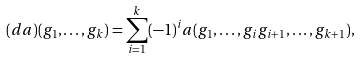<formula> <loc_0><loc_0><loc_500><loc_500>( d a ) ( g _ { 1 } , \dots , g _ { k } ) = \sum _ { i = 1 } ^ { k } ( - 1 ) ^ { i } a ( g _ { 1 } , \dots , g _ { i } g _ { i + 1 } , \dots , g _ { k + 1 } ) ,</formula> 